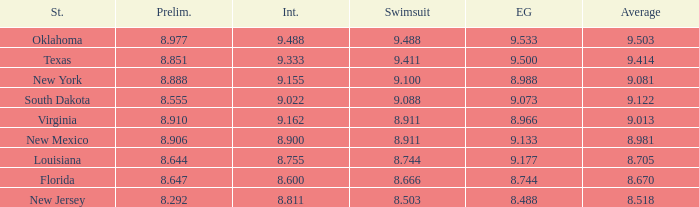 what's the evening gown where preliminaries is 8.977 9.533. 